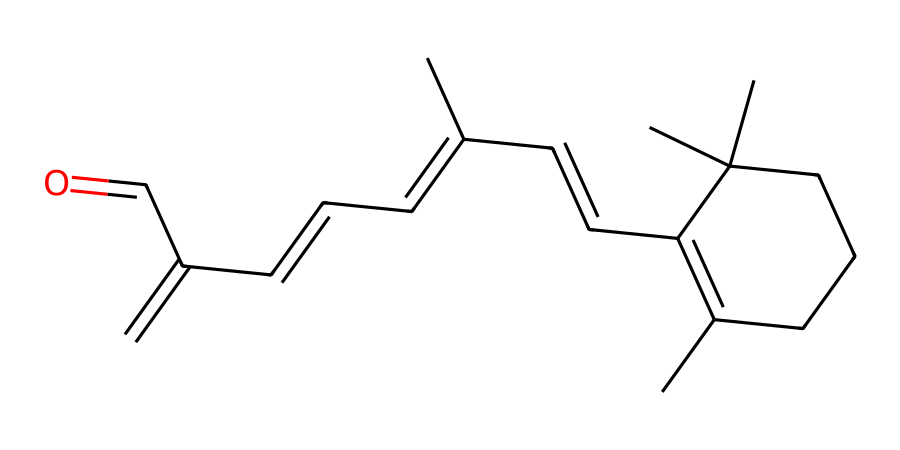What is the functional group present in this chemical structure? This structure has an aldehyde functional group indicated by the -C=O bond at the end of the carbon chain, which is typically found in retinol derivatives.
Answer: aldehyde How many carbon atoms are in this molecule? By analyzing the structure, each "C" in the SMILES represents a carbon atom, and counting all of them gives a total of 21 carbon atoms in the structure.
Answer: 21 What type of chemical is this compound primarily classified as? Given the structure features a long carbon chain with specific functional groups, this compound is classified as a retinoid, a group of compounds related to vitamin A.
Answer: retinoid How many double bonds are present in this chemical structure? By inspecting the bonds in the SMILES, there are 5 distinct double bonds connecting carbon atoms in various locations of the molecule.
Answer: 5 What is the significance of the aldehyde group in this chemical for anti-aging properties? Aldehyde groups in retinoids are known to promote cell turnover and improve skin texture, which is vital for anti-aging effects in cosmetics.
Answer: promotes cell turnover Where in this structure could you find the cyclic component? The structure shows a cyclic component formed by the ring structure, where the carbon atoms are bonded in a loop; this is visible as the initial part of the SMILES starting with "CC1=".
Answer: ring structure 